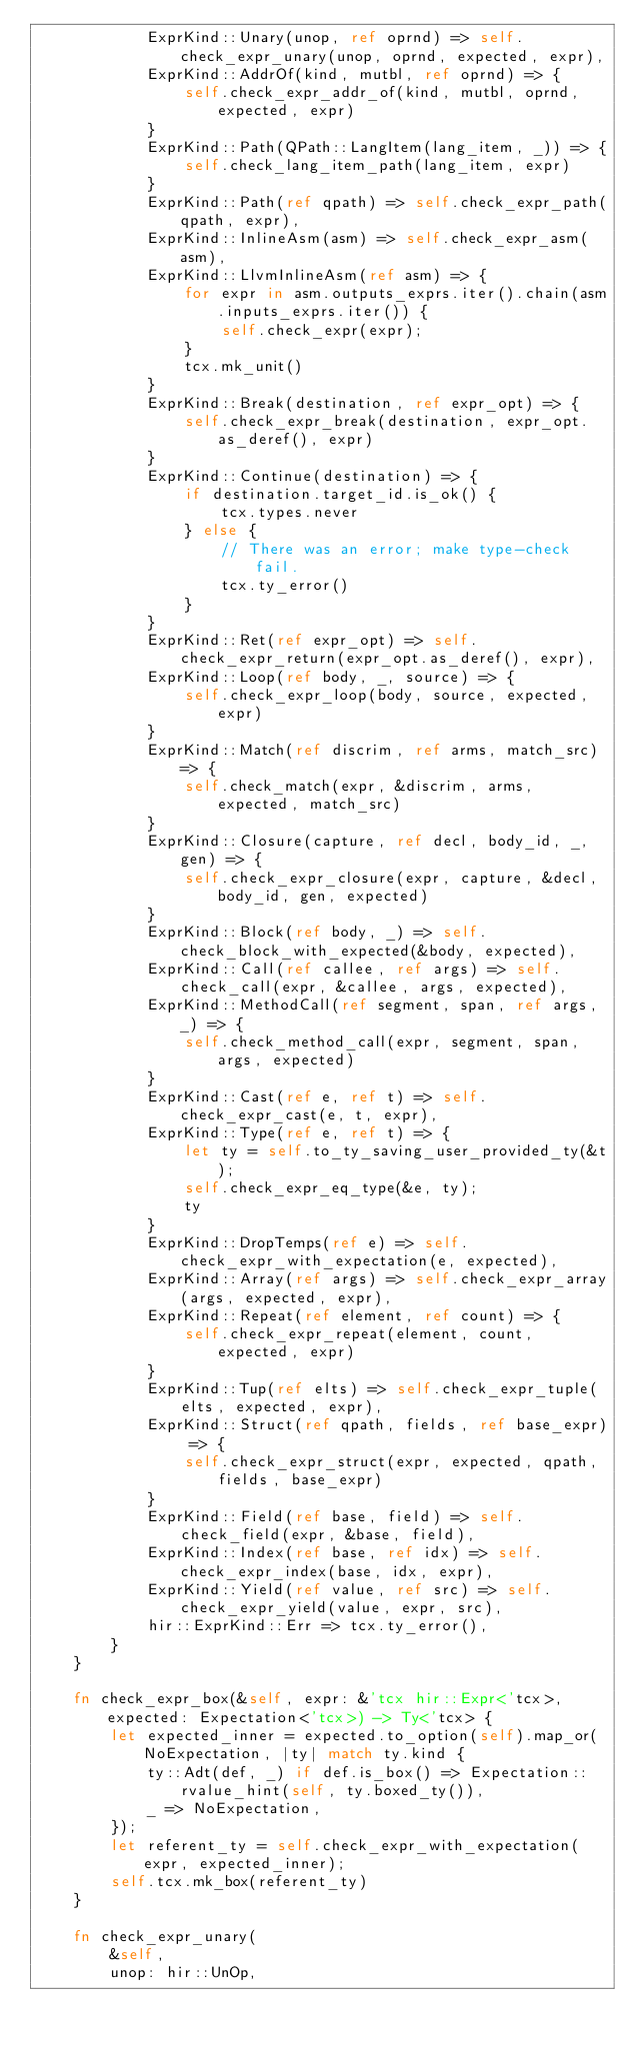<code> <loc_0><loc_0><loc_500><loc_500><_Rust_>            ExprKind::Unary(unop, ref oprnd) => self.check_expr_unary(unop, oprnd, expected, expr),
            ExprKind::AddrOf(kind, mutbl, ref oprnd) => {
                self.check_expr_addr_of(kind, mutbl, oprnd, expected, expr)
            }
            ExprKind::Path(QPath::LangItem(lang_item, _)) => {
                self.check_lang_item_path(lang_item, expr)
            }
            ExprKind::Path(ref qpath) => self.check_expr_path(qpath, expr),
            ExprKind::InlineAsm(asm) => self.check_expr_asm(asm),
            ExprKind::LlvmInlineAsm(ref asm) => {
                for expr in asm.outputs_exprs.iter().chain(asm.inputs_exprs.iter()) {
                    self.check_expr(expr);
                }
                tcx.mk_unit()
            }
            ExprKind::Break(destination, ref expr_opt) => {
                self.check_expr_break(destination, expr_opt.as_deref(), expr)
            }
            ExprKind::Continue(destination) => {
                if destination.target_id.is_ok() {
                    tcx.types.never
                } else {
                    // There was an error; make type-check fail.
                    tcx.ty_error()
                }
            }
            ExprKind::Ret(ref expr_opt) => self.check_expr_return(expr_opt.as_deref(), expr),
            ExprKind::Loop(ref body, _, source) => {
                self.check_expr_loop(body, source, expected, expr)
            }
            ExprKind::Match(ref discrim, ref arms, match_src) => {
                self.check_match(expr, &discrim, arms, expected, match_src)
            }
            ExprKind::Closure(capture, ref decl, body_id, _, gen) => {
                self.check_expr_closure(expr, capture, &decl, body_id, gen, expected)
            }
            ExprKind::Block(ref body, _) => self.check_block_with_expected(&body, expected),
            ExprKind::Call(ref callee, ref args) => self.check_call(expr, &callee, args, expected),
            ExprKind::MethodCall(ref segment, span, ref args, _) => {
                self.check_method_call(expr, segment, span, args, expected)
            }
            ExprKind::Cast(ref e, ref t) => self.check_expr_cast(e, t, expr),
            ExprKind::Type(ref e, ref t) => {
                let ty = self.to_ty_saving_user_provided_ty(&t);
                self.check_expr_eq_type(&e, ty);
                ty
            }
            ExprKind::DropTemps(ref e) => self.check_expr_with_expectation(e, expected),
            ExprKind::Array(ref args) => self.check_expr_array(args, expected, expr),
            ExprKind::Repeat(ref element, ref count) => {
                self.check_expr_repeat(element, count, expected, expr)
            }
            ExprKind::Tup(ref elts) => self.check_expr_tuple(elts, expected, expr),
            ExprKind::Struct(ref qpath, fields, ref base_expr) => {
                self.check_expr_struct(expr, expected, qpath, fields, base_expr)
            }
            ExprKind::Field(ref base, field) => self.check_field(expr, &base, field),
            ExprKind::Index(ref base, ref idx) => self.check_expr_index(base, idx, expr),
            ExprKind::Yield(ref value, ref src) => self.check_expr_yield(value, expr, src),
            hir::ExprKind::Err => tcx.ty_error(),
        }
    }

    fn check_expr_box(&self, expr: &'tcx hir::Expr<'tcx>, expected: Expectation<'tcx>) -> Ty<'tcx> {
        let expected_inner = expected.to_option(self).map_or(NoExpectation, |ty| match ty.kind {
            ty::Adt(def, _) if def.is_box() => Expectation::rvalue_hint(self, ty.boxed_ty()),
            _ => NoExpectation,
        });
        let referent_ty = self.check_expr_with_expectation(expr, expected_inner);
        self.tcx.mk_box(referent_ty)
    }

    fn check_expr_unary(
        &self,
        unop: hir::UnOp,</code> 